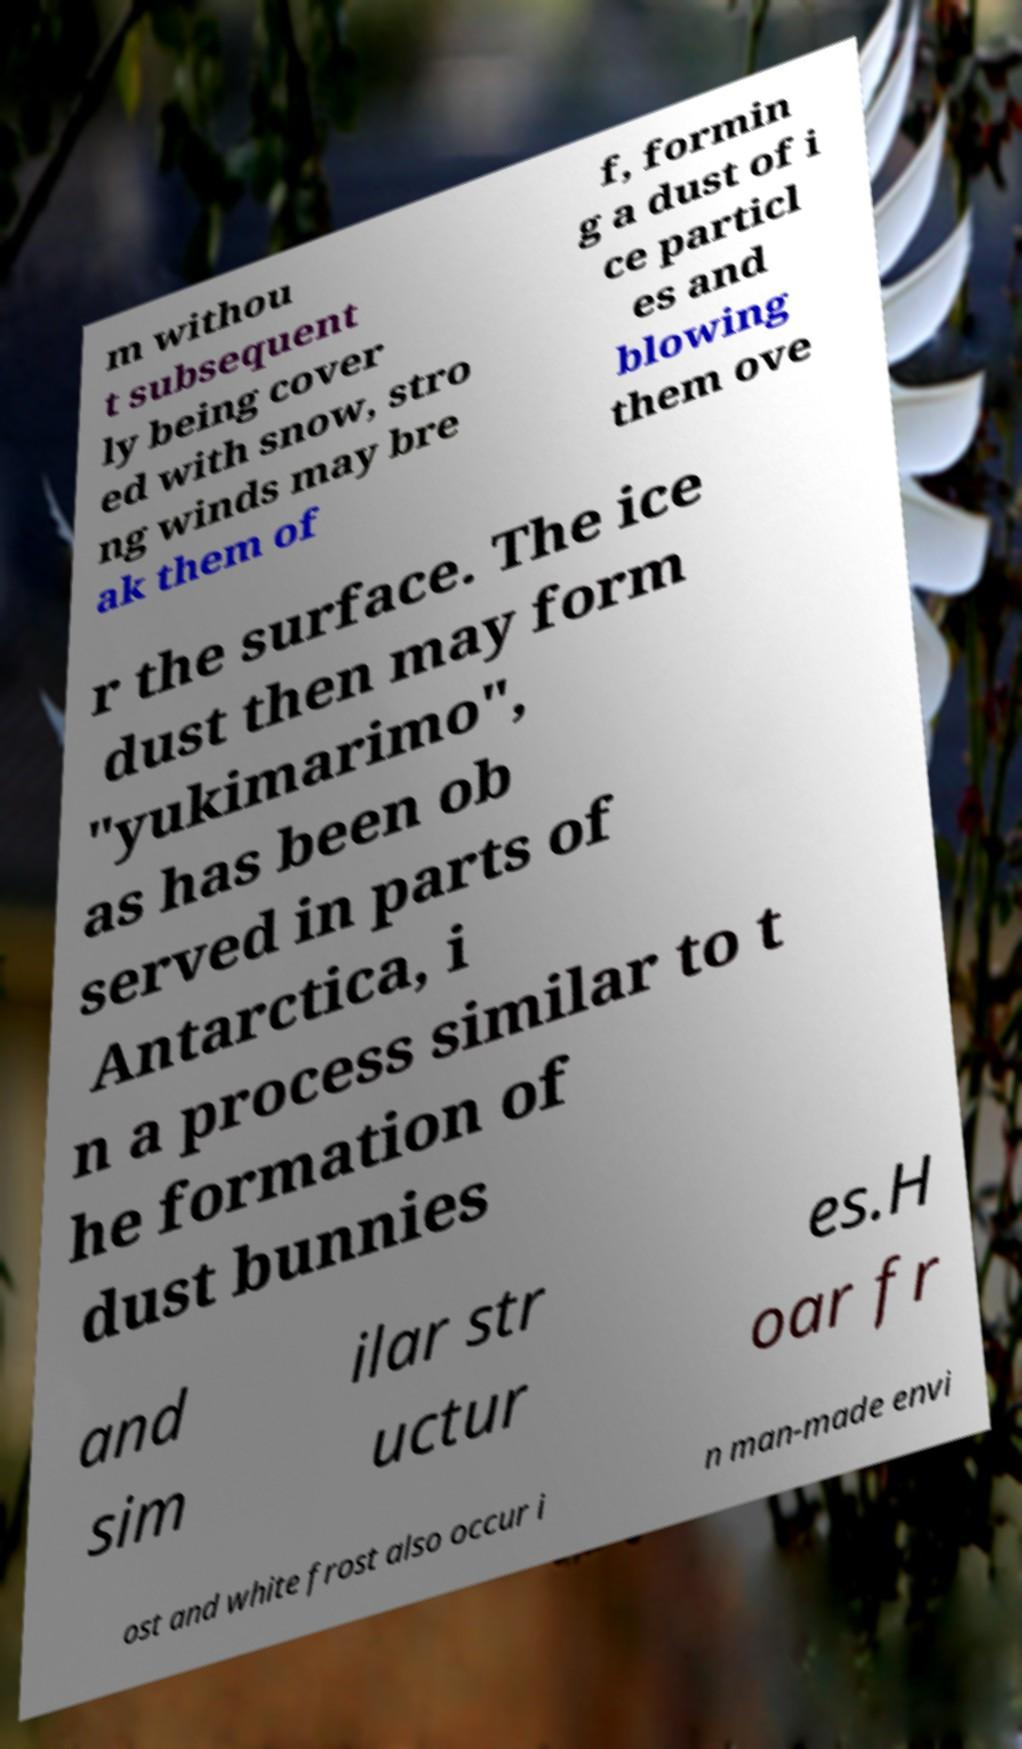Could you assist in decoding the text presented in this image and type it out clearly? m withou t subsequent ly being cover ed with snow, stro ng winds may bre ak them of f, formin g a dust of i ce particl es and blowing them ove r the surface. The ice dust then may form "yukimarimo", as has been ob served in parts of Antarctica, i n a process similar to t he formation of dust bunnies and sim ilar str uctur es.H oar fr ost and white frost also occur i n man-made envi 